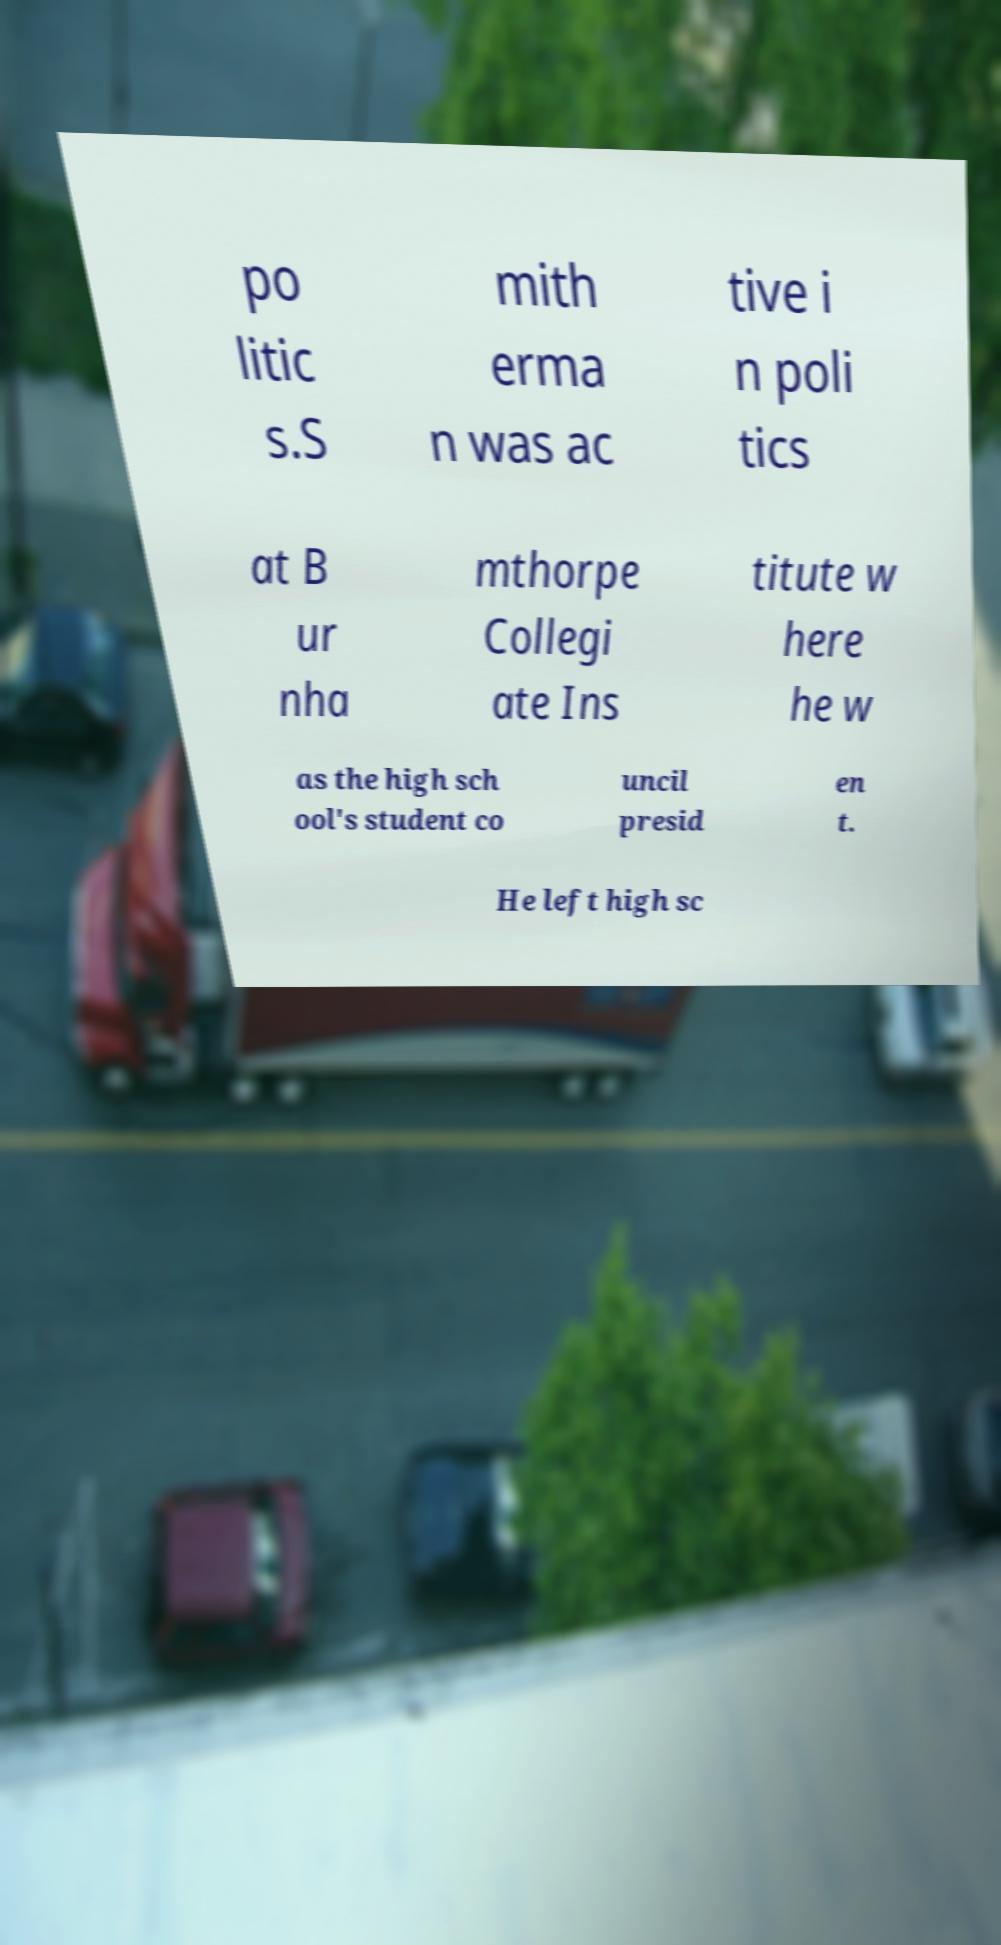Please read and relay the text visible in this image. What does it say? po litic s.S mith erma n was ac tive i n poli tics at B ur nha mthorpe Collegi ate Ins titute w here he w as the high sch ool's student co uncil presid en t. He left high sc 